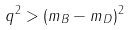Convert formula to latex. <formula><loc_0><loc_0><loc_500><loc_500>q ^ { 2 } > ( m _ { B } - m _ { D } ) ^ { 2 }</formula> 